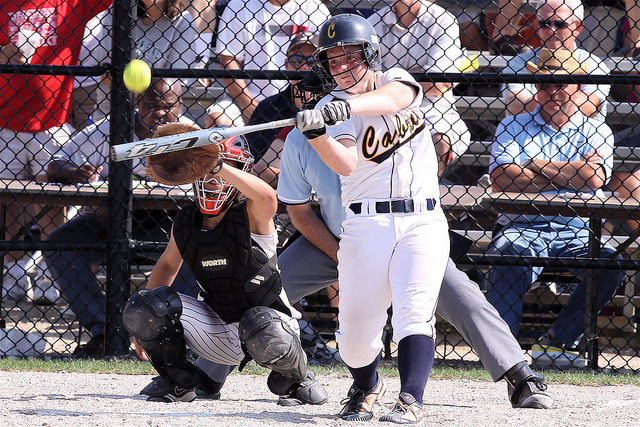Considering the positions of the batter, ball, and catcher, can you infer the outcome of this pitch? From the positions of the batter, ball, and catcher, it appears the batter is making a strong swing towards the ball. While it’s hard to determine the exact outcome, the proximity of the ball to the bat suggests that the batter is making a committed attempt to hit the ball. 